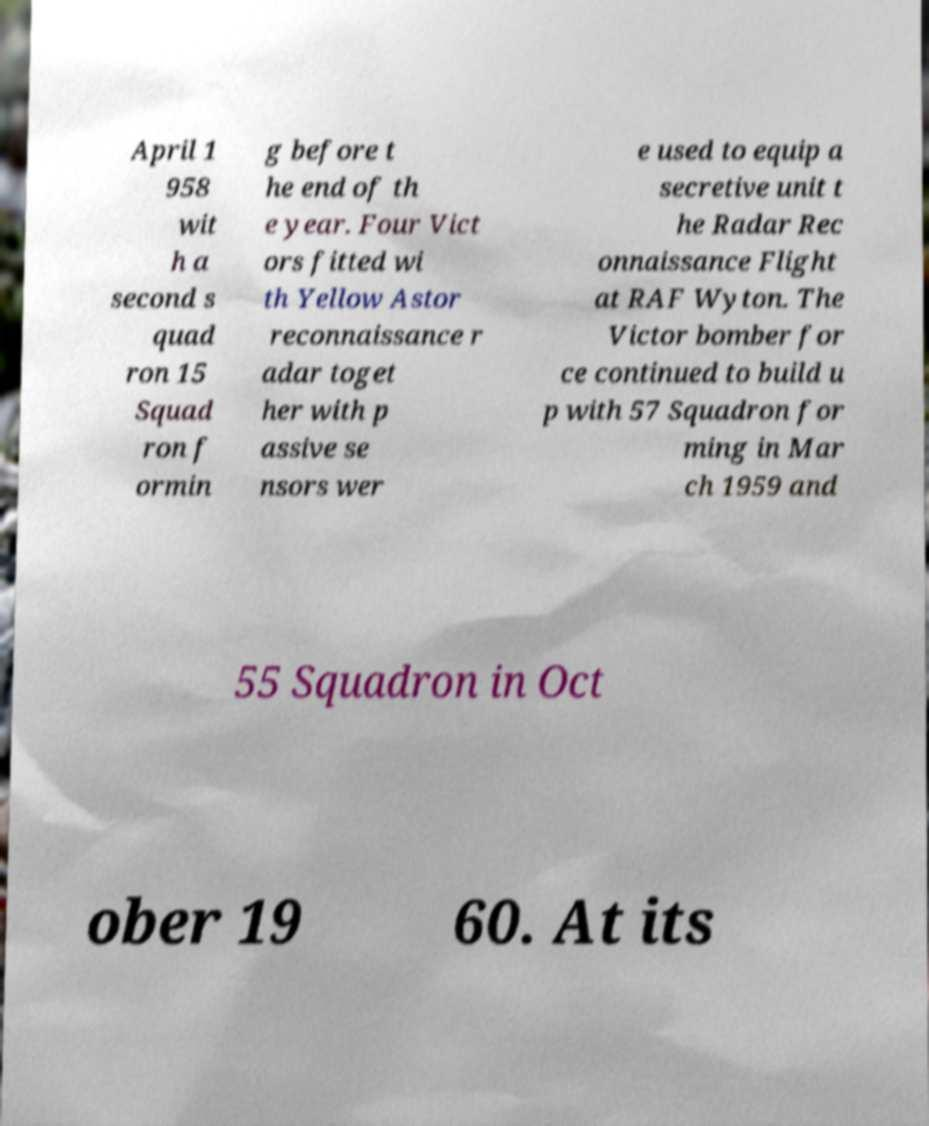What messages or text are displayed in this image? I need them in a readable, typed format. April 1 958 wit h a second s quad ron 15 Squad ron f ormin g before t he end of th e year. Four Vict ors fitted wi th Yellow Astor reconnaissance r adar toget her with p assive se nsors wer e used to equip a secretive unit t he Radar Rec onnaissance Flight at RAF Wyton. The Victor bomber for ce continued to build u p with 57 Squadron for ming in Mar ch 1959 and 55 Squadron in Oct ober 19 60. At its 